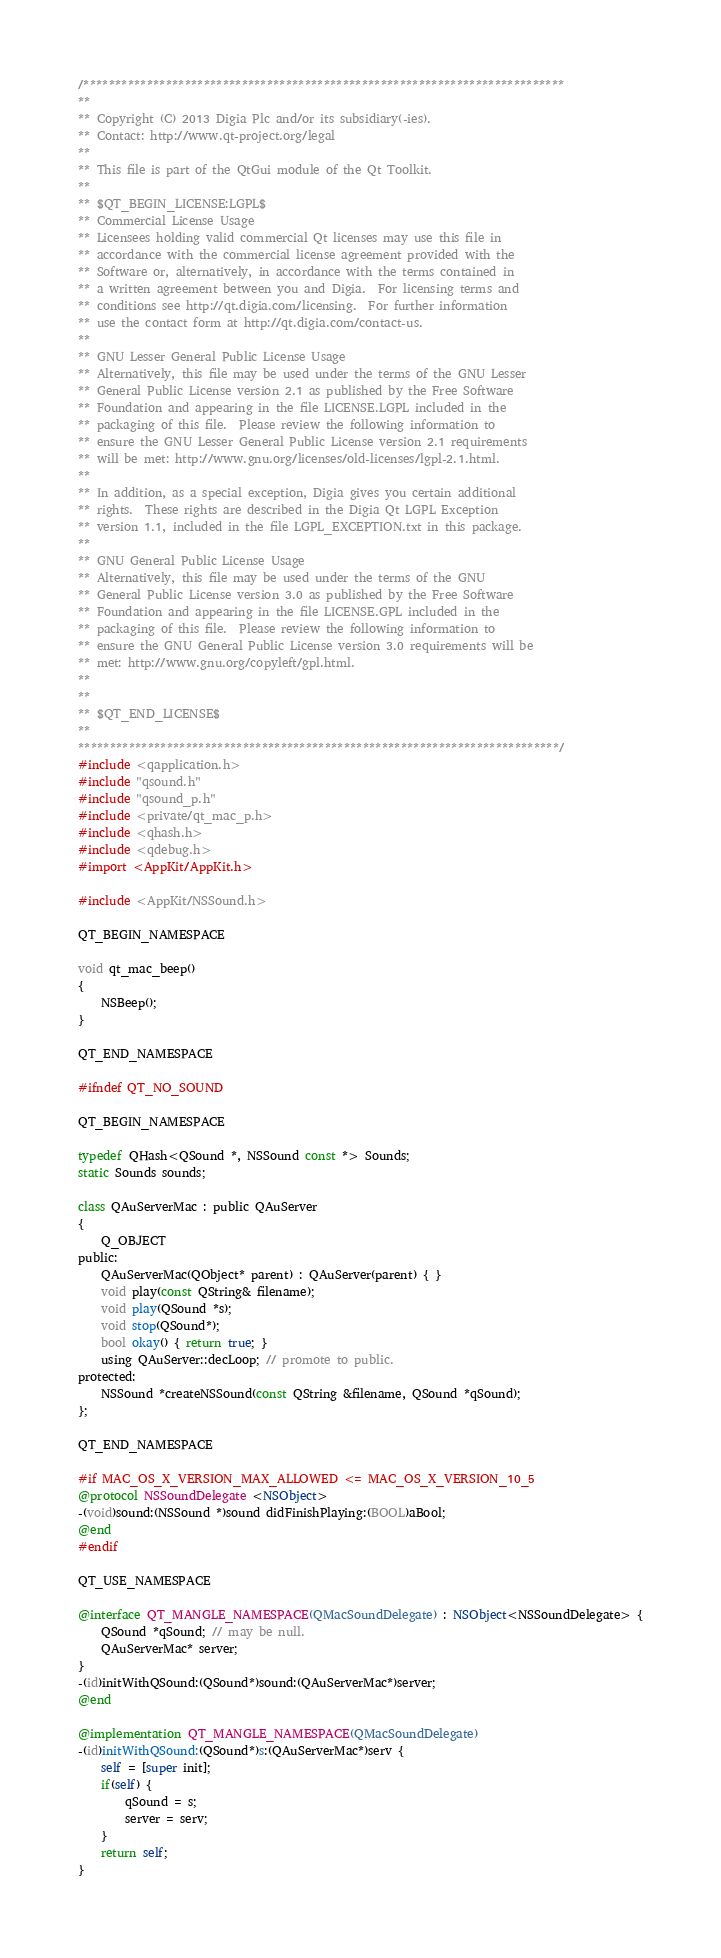Convert code to text. <code><loc_0><loc_0><loc_500><loc_500><_ObjectiveC_>/****************************************************************************
**
** Copyright (C) 2013 Digia Plc and/or its subsidiary(-ies).
** Contact: http://www.qt-project.org/legal
**
** This file is part of the QtGui module of the Qt Toolkit.
**
** $QT_BEGIN_LICENSE:LGPL$
** Commercial License Usage
** Licensees holding valid commercial Qt licenses may use this file in
** accordance with the commercial license agreement provided with the
** Software or, alternatively, in accordance with the terms contained in
** a written agreement between you and Digia.  For licensing terms and
** conditions see http://qt.digia.com/licensing.  For further information
** use the contact form at http://qt.digia.com/contact-us.
**
** GNU Lesser General Public License Usage
** Alternatively, this file may be used under the terms of the GNU Lesser
** General Public License version 2.1 as published by the Free Software
** Foundation and appearing in the file LICENSE.LGPL included in the
** packaging of this file.  Please review the following information to
** ensure the GNU Lesser General Public License version 2.1 requirements
** will be met: http://www.gnu.org/licenses/old-licenses/lgpl-2.1.html.
**
** In addition, as a special exception, Digia gives you certain additional
** rights.  These rights are described in the Digia Qt LGPL Exception
** version 1.1, included in the file LGPL_EXCEPTION.txt in this package.
**
** GNU General Public License Usage
** Alternatively, this file may be used under the terms of the GNU
** General Public License version 3.0 as published by the Free Software
** Foundation and appearing in the file LICENSE.GPL included in the
** packaging of this file.  Please review the following information to
** ensure the GNU General Public License version 3.0 requirements will be
** met: http://www.gnu.org/copyleft/gpl.html.
**
**
** $QT_END_LICENSE$
**
****************************************************************************/
#include <qapplication.h>
#include "qsound.h"
#include "qsound_p.h"
#include <private/qt_mac_p.h>
#include <qhash.h>
#include <qdebug.h>
#import <AppKit/AppKit.h>

#include <AppKit/NSSound.h>

QT_BEGIN_NAMESPACE

void qt_mac_beep() 
{
    NSBeep();
}

QT_END_NAMESPACE

#ifndef QT_NO_SOUND

QT_BEGIN_NAMESPACE

typedef QHash<QSound *, NSSound const *> Sounds;
static Sounds sounds;

class QAuServerMac : public QAuServer
{
    Q_OBJECT
public:
    QAuServerMac(QObject* parent) : QAuServer(parent) { }
    void play(const QString& filename);
    void play(QSound *s);
    void stop(QSound*);
    bool okay() { return true; }
    using QAuServer::decLoop; // promote to public.
protected:
    NSSound *createNSSound(const QString &filename, QSound *qSound);
};

QT_END_NAMESPACE

#if MAC_OS_X_VERSION_MAX_ALLOWED <= MAC_OS_X_VERSION_10_5
@protocol NSSoundDelegate <NSObject>
-(void)sound:(NSSound *)sound didFinishPlaying:(BOOL)aBool;
@end
#endif

QT_USE_NAMESPACE

@interface QT_MANGLE_NAMESPACE(QMacSoundDelegate) : NSObject<NSSoundDelegate> {
    QSound *qSound; // may be null.
    QAuServerMac* server;
}
-(id)initWithQSound:(QSound*)sound:(QAuServerMac*)server;
@end

@implementation QT_MANGLE_NAMESPACE(QMacSoundDelegate)
-(id)initWithQSound:(QSound*)s:(QAuServerMac*)serv {
    self = [super init];
    if(self) {
        qSound = s;
        server = serv;
    }
    return self;
}
</code> 